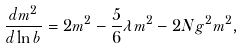Convert formula to latex. <formula><loc_0><loc_0><loc_500><loc_500>\frac { d m ^ { 2 } } { d \ln { b } } = 2 m ^ { 2 } - \frac { 5 } { 6 } \lambda m ^ { 2 } - 2 N g ^ { 2 } m ^ { 2 } ,</formula> 